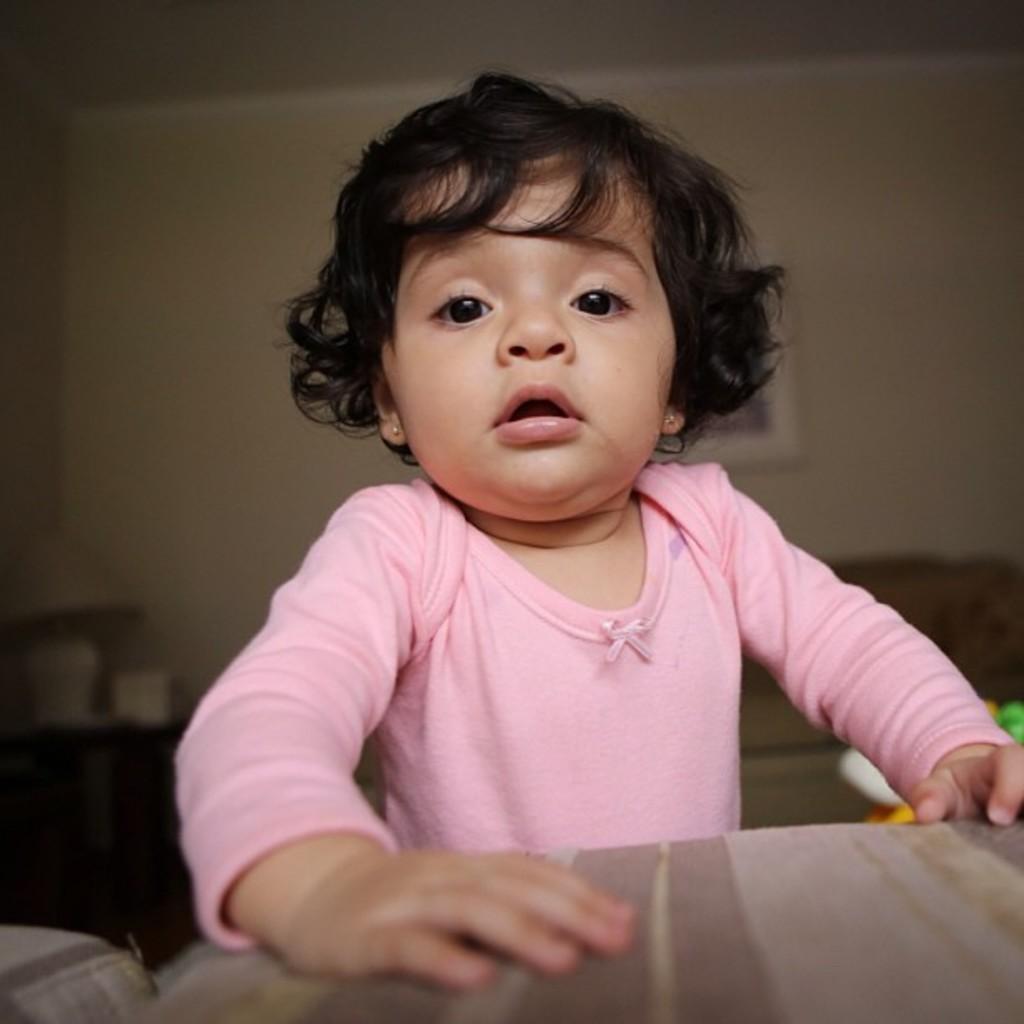Describe this image in one or two sentences. In this image there is a child standing, there is an object truncated towards the bottom of the image, there are objects truncated towards the left of the image, there are objects truncated towards the right of the image, there is a photo frame, at the background of the image there is a wall truncated, towards the top of the image there is a roof truncated. 